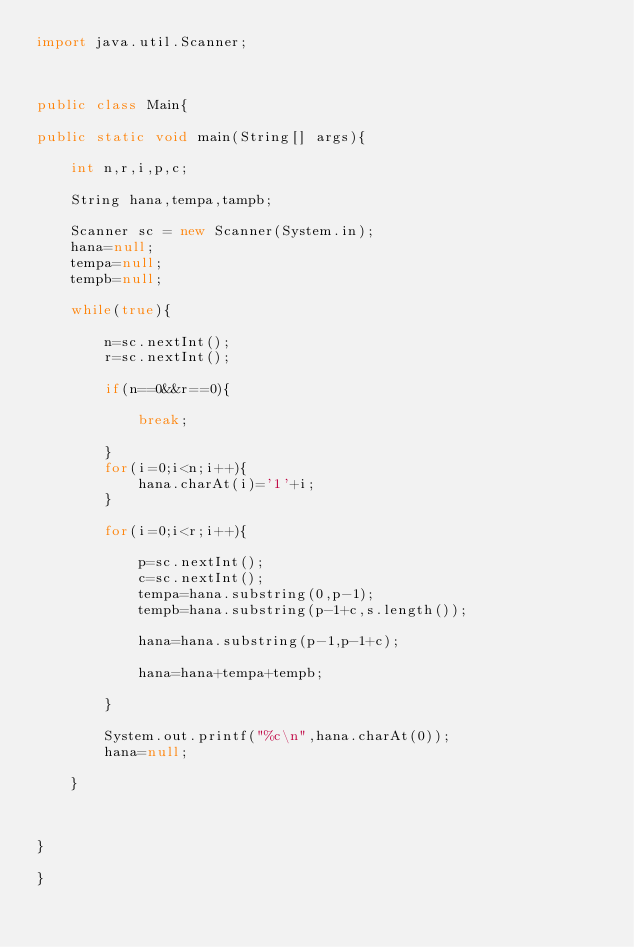<code> <loc_0><loc_0><loc_500><loc_500><_Java_>import java.util.Scanner;



public class Main{

public static void main(String[] args){

	int n,r,i,p,c;

	String hana,tempa,tampb;

	Scanner sc = new Scanner(System.in);
	hana=null;
	tempa=null;
	tempb=null;

	while(true){

		n=sc.nextInt();
		r=sc.nextInt();

		if(n==0&&r==0){

			break;

		}
		for(i=0;i<n;i++){
			hana.charAt(i)='1'+i;
		}

		for(i=0;i<r;i++){

			p=sc.nextInt();
			c=sc.nextInt();
			tempa=hana.substring(0,p-1);
			tempb=hana.substring(p-1+c,s.length());

			hana=hana.substring(p-1,p-1+c);

			hana=hana+tempa+tempb;

		}

		System.out.printf("%c\n",hana.charAt(0));
		hana=null;

	}



}

}</code> 